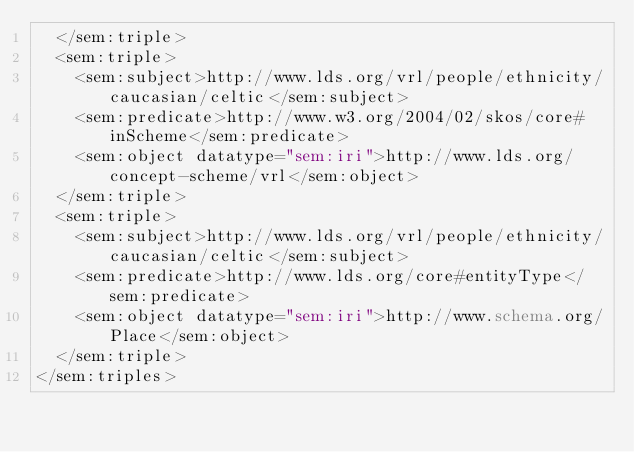<code> <loc_0><loc_0><loc_500><loc_500><_XML_>  </sem:triple>
  <sem:triple>
    <sem:subject>http://www.lds.org/vrl/people/ethnicity/caucasian/celtic</sem:subject>
    <sem:predicate>http://www.w3.org/2004/02/skos/core#inScheme</sem:predicate>
    <sem:object datatype="sem:iri">http://www.lds.org/concept-scheme/vrl</sem:object>
  </sem:triple>
  <sem:triple>
    <sem:subject>http://www.lds.org/vrl/people/ethnicity/caucasian/celtic</sem:subject>
    <sem:predicate>http://www.lds.org/core#entityType</sem:predicate>
    <sem:object datatype="sem:iri">http://www.schema.org/Place</sem:object>
  </sem:triple>
</sem:triples>
</code> 